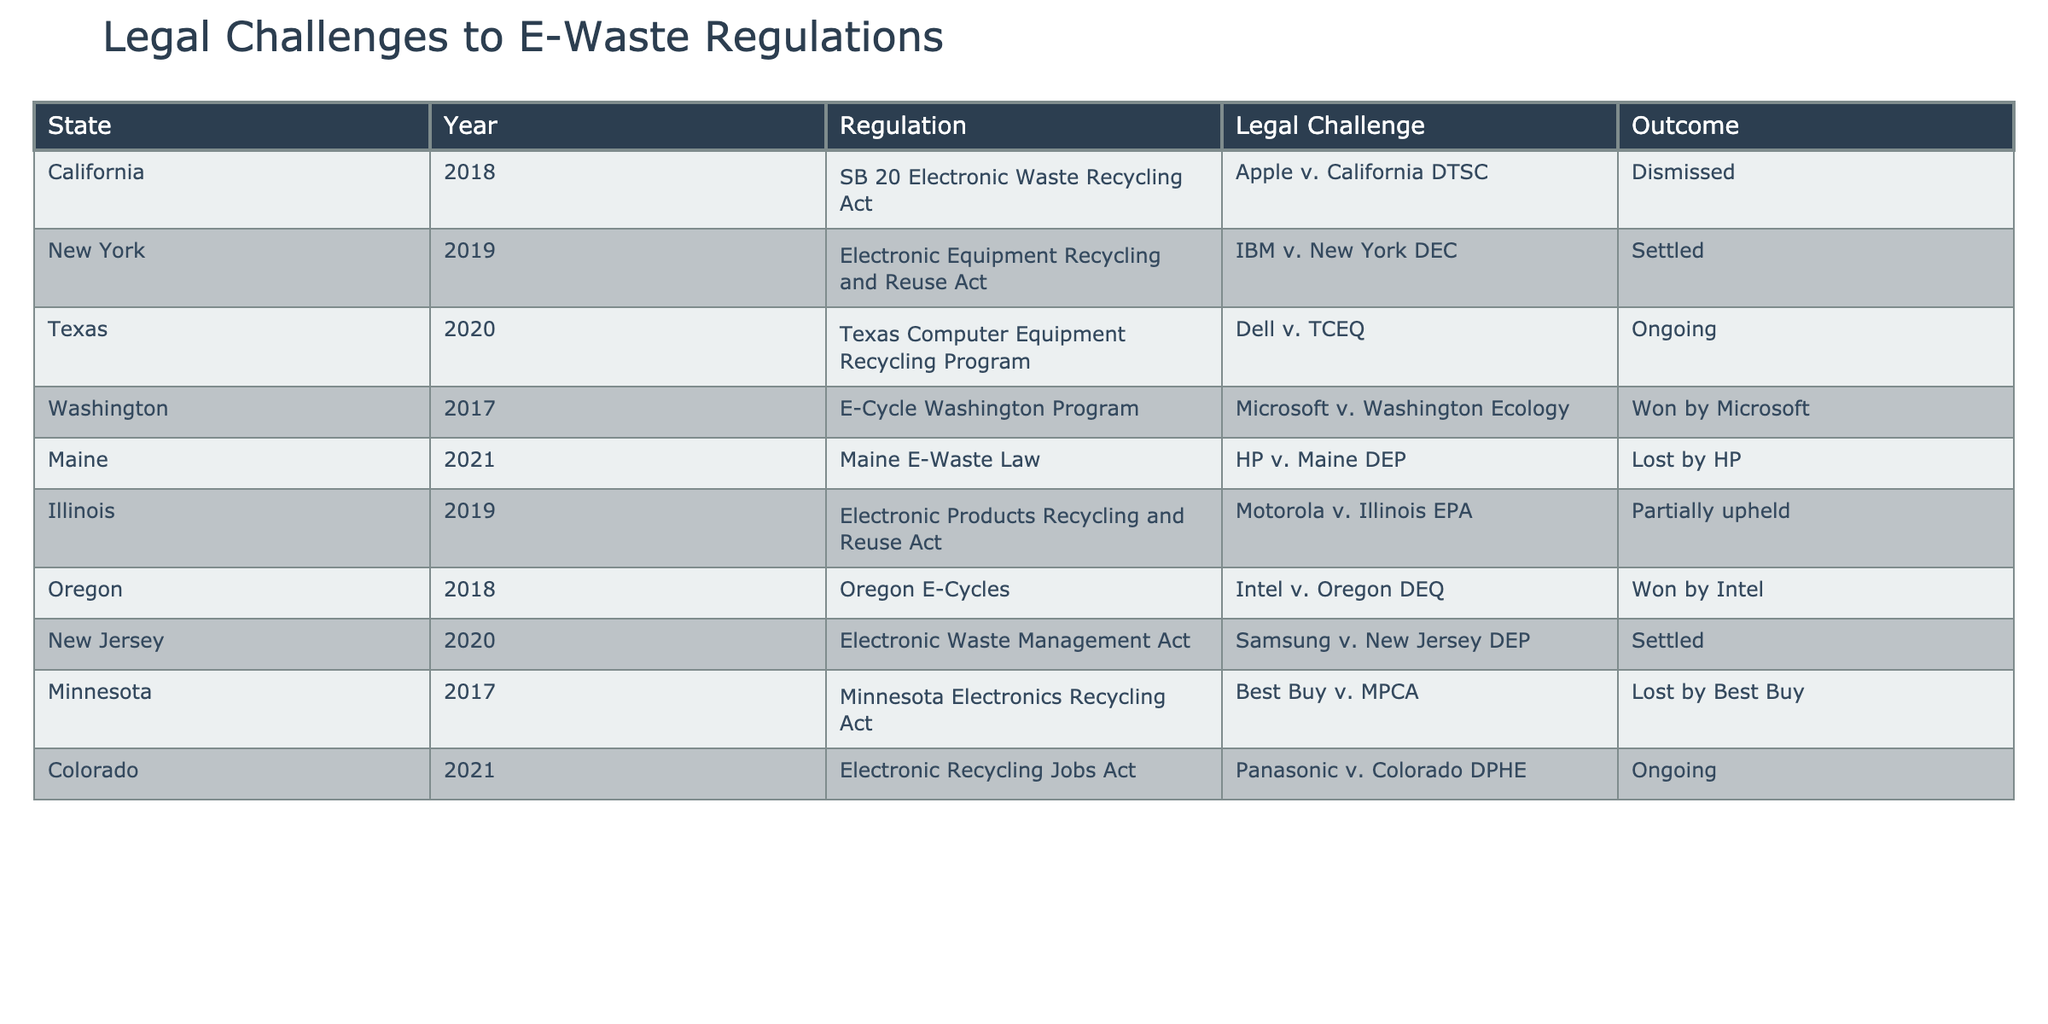What was the outcome of the legal challenge involving HP in Maine? The table shows that HP v. Maine DEP was lost by HP, indicating that the challenge was not successful.
Answer: Lost by HP How many legal challenges were ongoing as of the most recent data? There are two ongoing legal challenges listed in the table: Dell v. TCEQ in Texas and Panasonic v. Colorado DPHE.
Answer: 2 Which state had a legal challenge that was won by a corporation? The table shows that Microsoft won their legal challenge against Washington Ecology.
Answer: Washington In how many states did the electronic waste regulations lead to a settled legal challenge? According to the table, there are two settled cases: IBM v. New York DEC and Samsung v. New Jersey DEP.
Answer: 2 What is the outcome of the legal challenge brought by Dell in Texas? The table indicates that the legal challenge brought by Dell against TCEQ is ongoing, meaning it has not been resolved yet.
Answer: Ongoing Which state had a partial uphold of its electronic waste regulation? The table reveals that the legal challenge Motorola v. Illinois EPA resulted in a partial uphold, indicating some elements were maintained.
Answer: Illinois Was there any legal challenge in Washington that resulted in a loss for the corporation? Looking at the table, there were no losses for corporations in Washington; Microsoft won against Washington Ecology.
Answer: No Compare the outcomes of legal challenges in California and New Jersey. In California, Apple’s challenge was dismissed, while in New Jersey, Samsung's challenge was settled; thus, California faced a definitive ruling while New Jersey’s case was resolved differently.
Answer: Different outcomes Which corporation faced legal challenges that resulted in a loss? The table lists two corporations, HP and Best Buy, which both lost their respective legal challenges in Maine and Minnesota.
Answer: HP and Best Buy What percentage of the total legal challenges listed were won by corporations? There are 10 legal challenges; 3 are noted as won (Microsoft and Intel), so the percentage calculation is (3/10)*100 = 30%.
Answer: 30% 